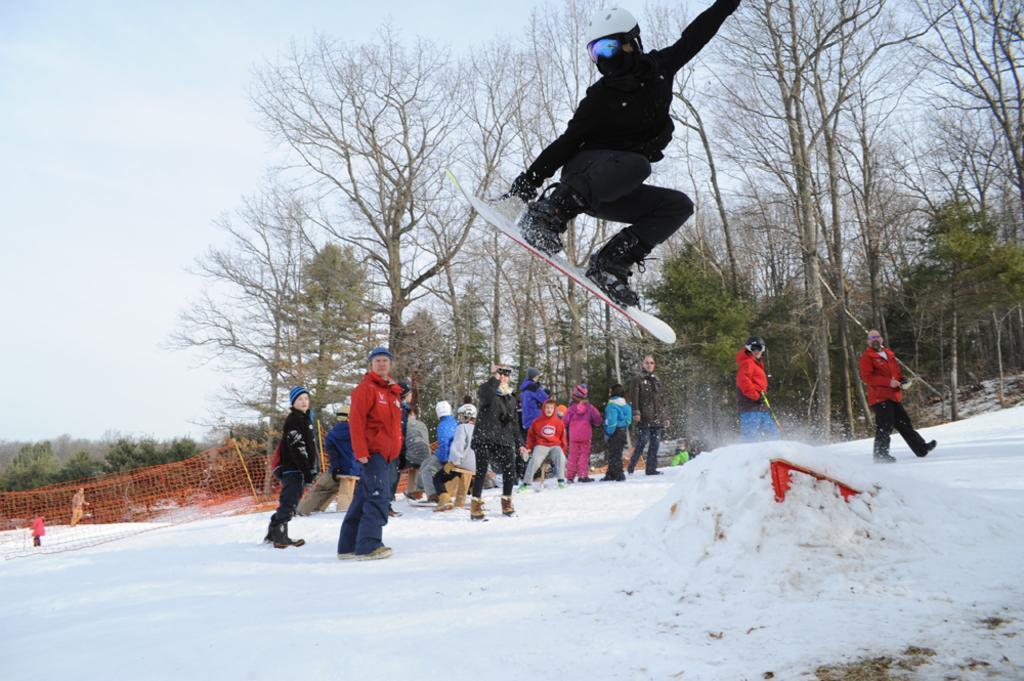Please provide a concise description of this image. The person wearing black dress placed his legs on a ski which is in the air and there are few persons standing beside him and there are trees in the background. 